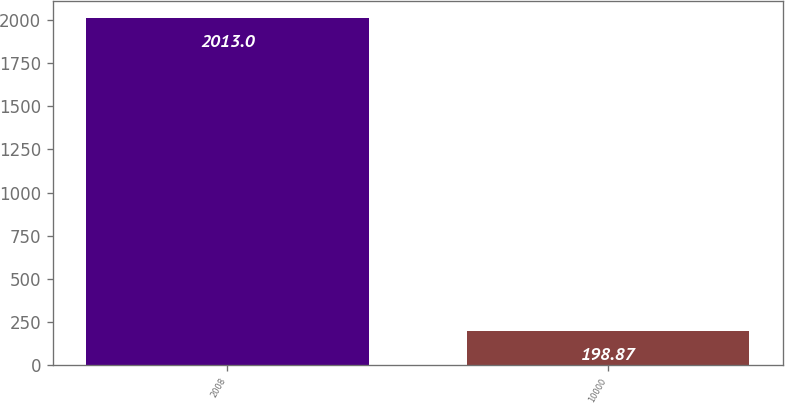Convert chart to OTSL. <chart><loc_0><loc_0><loc_500><loc_500><bar_chart><fcel>2008<fcel>10000<nl><fcel>2013<fcel>198.87<nl></chart> 